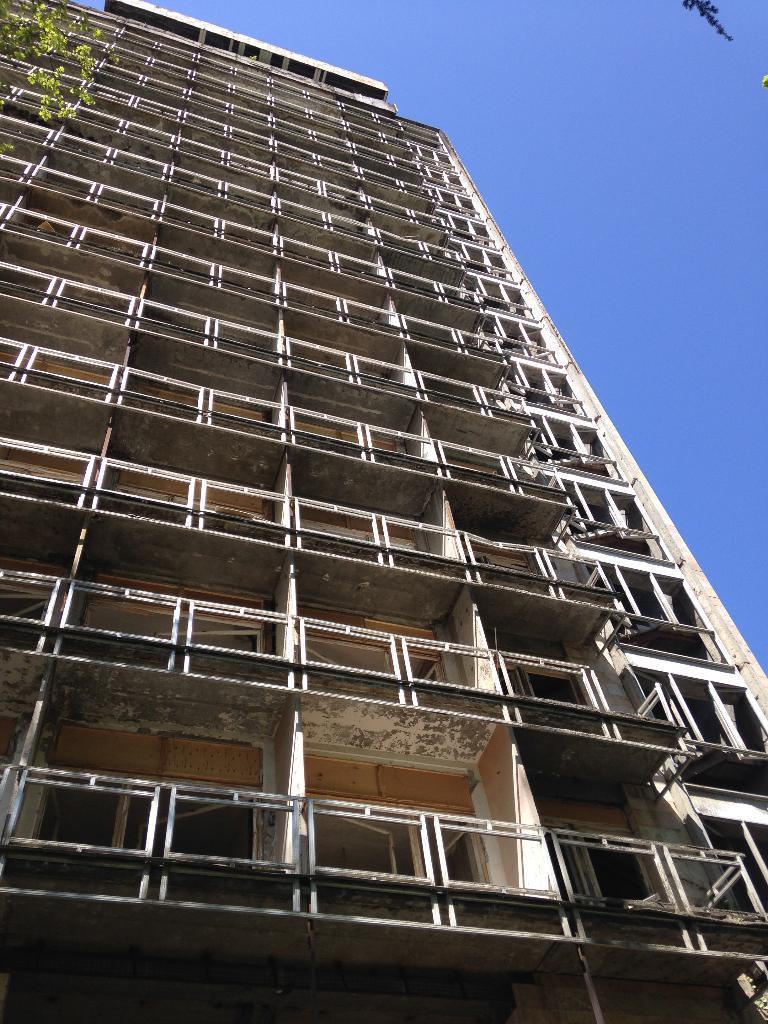Describe this image in one or two sentences. In this image we can see a building and it is having many windows to it. There is a sky in the image. There is a tree in the image. 